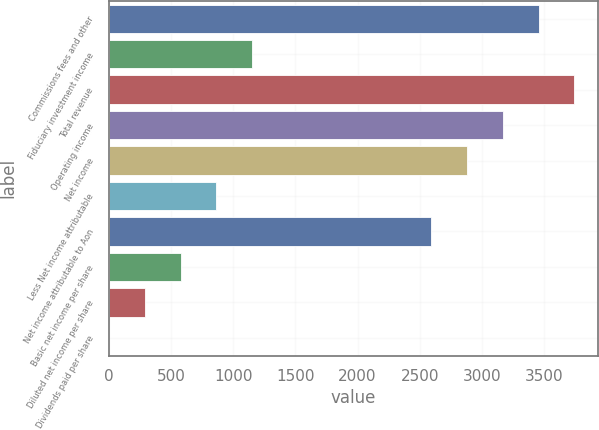Convert chart. <chart><loc_0><loc_0><loc_500><loc_500><bar_chart><fcel>Commissions fees and other<fcel>Fiduciary investment income<fcel>Total revenue<fcel>Operating income<fcel>Net income<fcel>Less Net income attributable<fcel>Net income attributable to Aon<fcel>Basic net income per share<fcel>Diluted net income per share<fcel>Dividends paid per share<nl><fcel>3455.99<fcel>1152.16<fcel>3743.96<fcel>3168.01<fcel>2880.03<fcel>864.19<fcel>2592.05<fcel>576.21<fcel>288.23<fcel>0.25<nl></chart> 